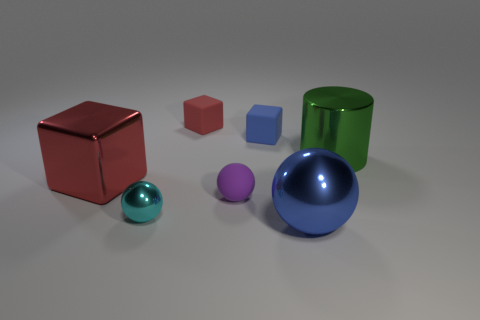There is a red thing that is made of the same material as the cylinder; what is its size?
Give a very brief answer. Large. The other matte cube that is the same color as the big cube is what size?
Provide a short and direct response. Small. What number of other objects are there of the same size as the purple ball?
Provide a succinct answer. 3. What is the material of the red cube that is on the left side of the cyan sphere?
Offer a very short reply. Metal. There is a blue thing behind the shiny thing that is on the right side of the metal sphere that is on the right side of the small purple matte ball; what shape is it?
Give a very brief answer. Cube. Is the blue ball the same size as the red matte block?
Provide a succinct answer. No. How many objects are yellow spheres or tiny things in front of the big green metal cylinder?
Provide a succinct answer. 2. What number of things are either objects behind the large blue metal object or balls that are on the right side of the rubber sphere?
Your answer should be compact. 7. Are there any blue balls on the right side of the large red thing?
Ensure brevity in your answer.  Yes. There is a cube that is in front of the thing that is right of the sphere in front of the cyan shiny object; what color is it?
Your answer should be compact. Red. 